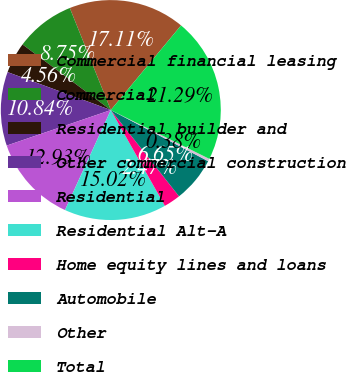Convert chart. <chart><loc_0><loc_0><loc_500><loc_500><pie_chart><fcel>Commercial financial leasing<fcel>Commercial<fcel>Residential builder and<fcel>Other commercial construction<fcel>Residential<fcel>Residential Alt-A<fcel>Home equity lines and loans<fcel>Automobile<fcel>Other<fcel>Total<nl><fcel>17.11%<fcel>8.75%<fcel>4.56%<fcel>10.84%<fcel>12.93%<fcel>15.02%<fcel>2.47%<fcel>6.65%<fcel>0.38%<fcel>21.29%<nl></chart> 